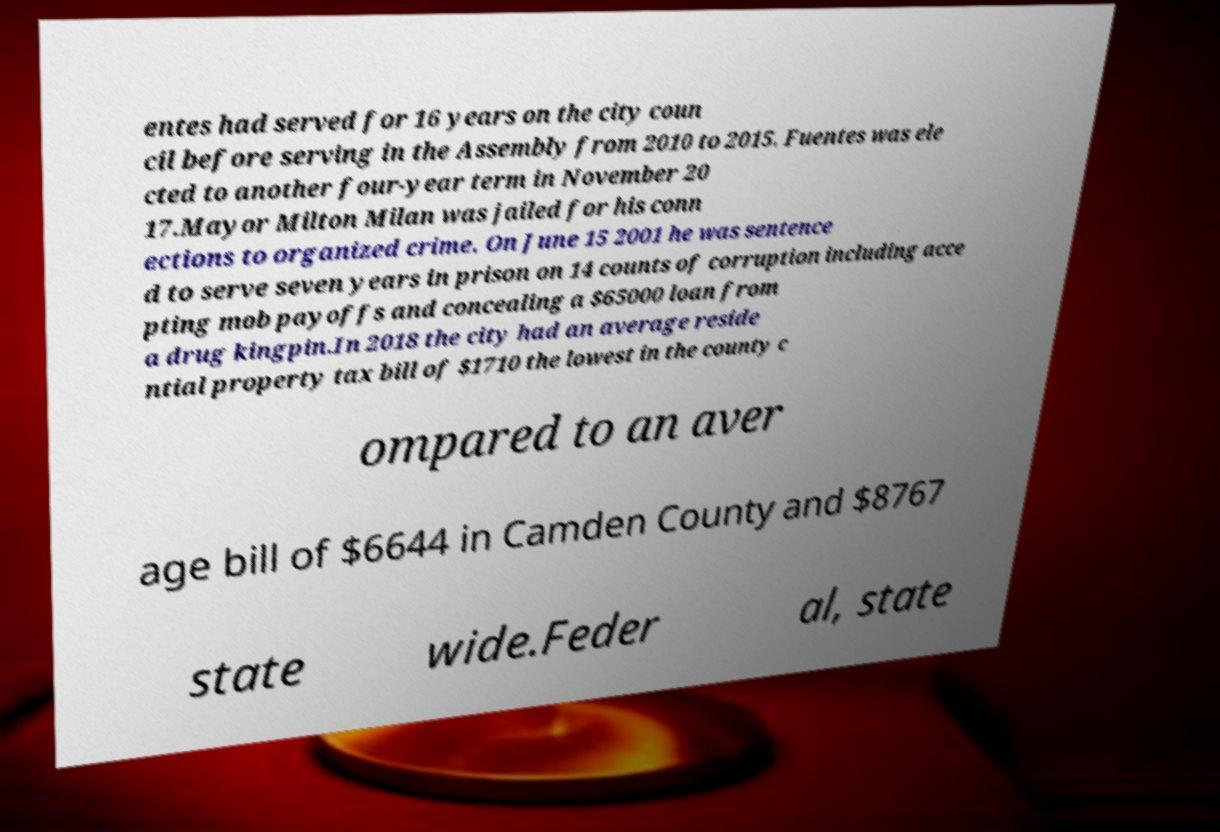For documentation purposes, I need the text within this image transcribed. Could you provide that? entes had served for 16 years on the city coun cil before serving in the Assembly from 2010 to 2015. Fuentes was ele cted to another four-year term in November 20 17.Mayor Milton Milan was jailed for his conn ections to organized crime. On June 15 2001 he was sentence d to serve seven years in prison on 14 counts of corruption including acce pting mob payoffs and concealing a $65000 loan from a drug kingpin.In 2018 the city had an average reside ntial property tax bill of $1710 the lowest in the county c ompared to an aver age bill of $6644 in Camden County and $8767 state wide.Feder al, state 